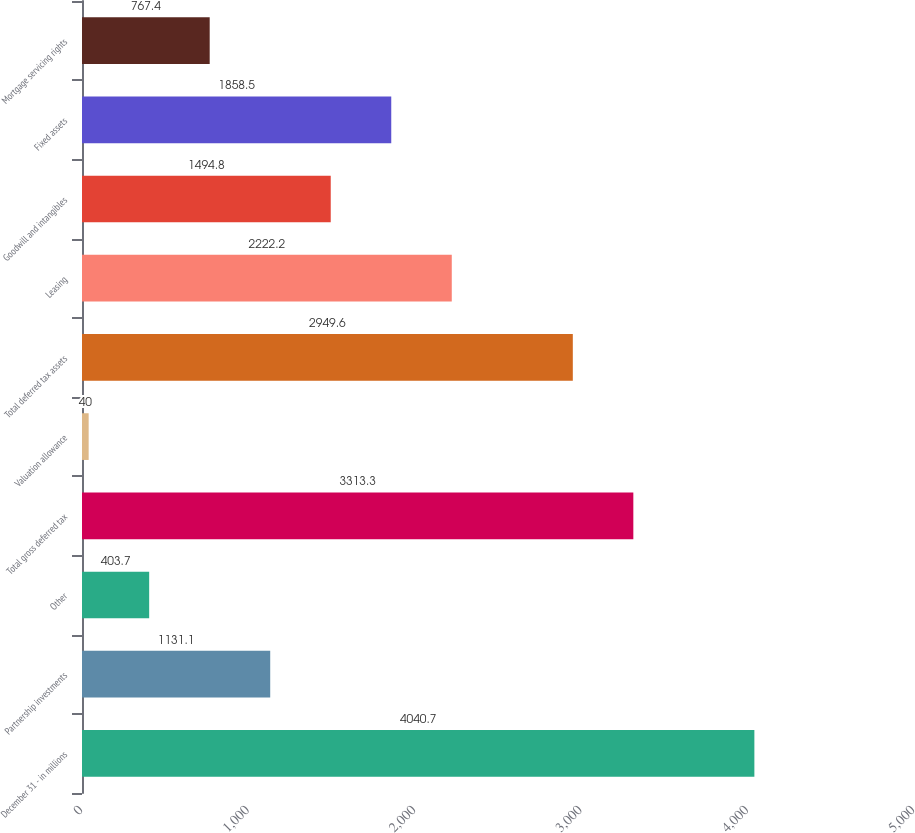<chart> <loc_0><loc_0><loc_500><loc_500><bar_chart><fcel>December 31 - in millions<fcel>Partnership investments<fcel>Other<fcel>Total gross deferred tax<fcel>Valuation allowance<fcel>Total deferred tax assets<fcel>Leasing<fcel>Goodwill and intangibles<fcel>Fixed assets<fcel>Mortgage servicing rights<nl><fcel>4040.7<fcel>1131.1<fcel>403.7<fcel>3313.3<fcel>40<fcel>2949.6<fcel>2222.2<fcel>1494.8<fcel>1858.5<fcel>767.4<nl></chart> 